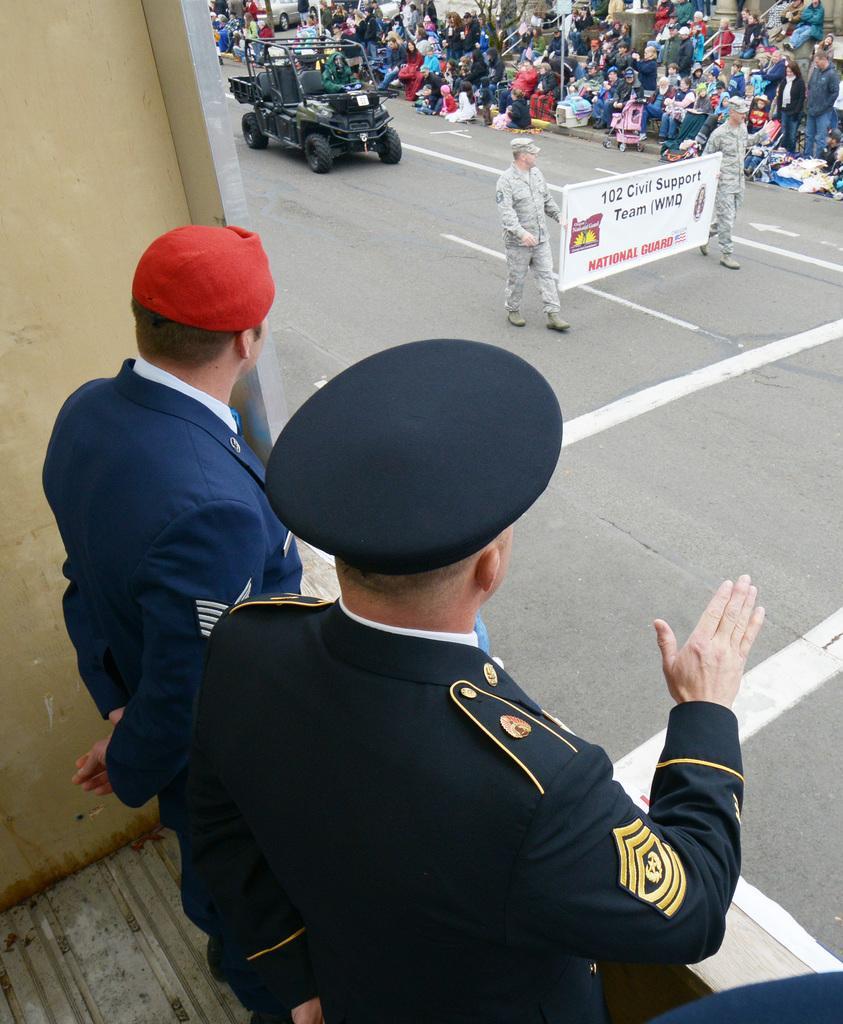Please provide a concise description of this image. 2 Men are standing and observing this. In the middle 2 men are walking by holding the banner in their hands, behind them a jeep is moving on the road. On the right side few persons are observing these things from there. 